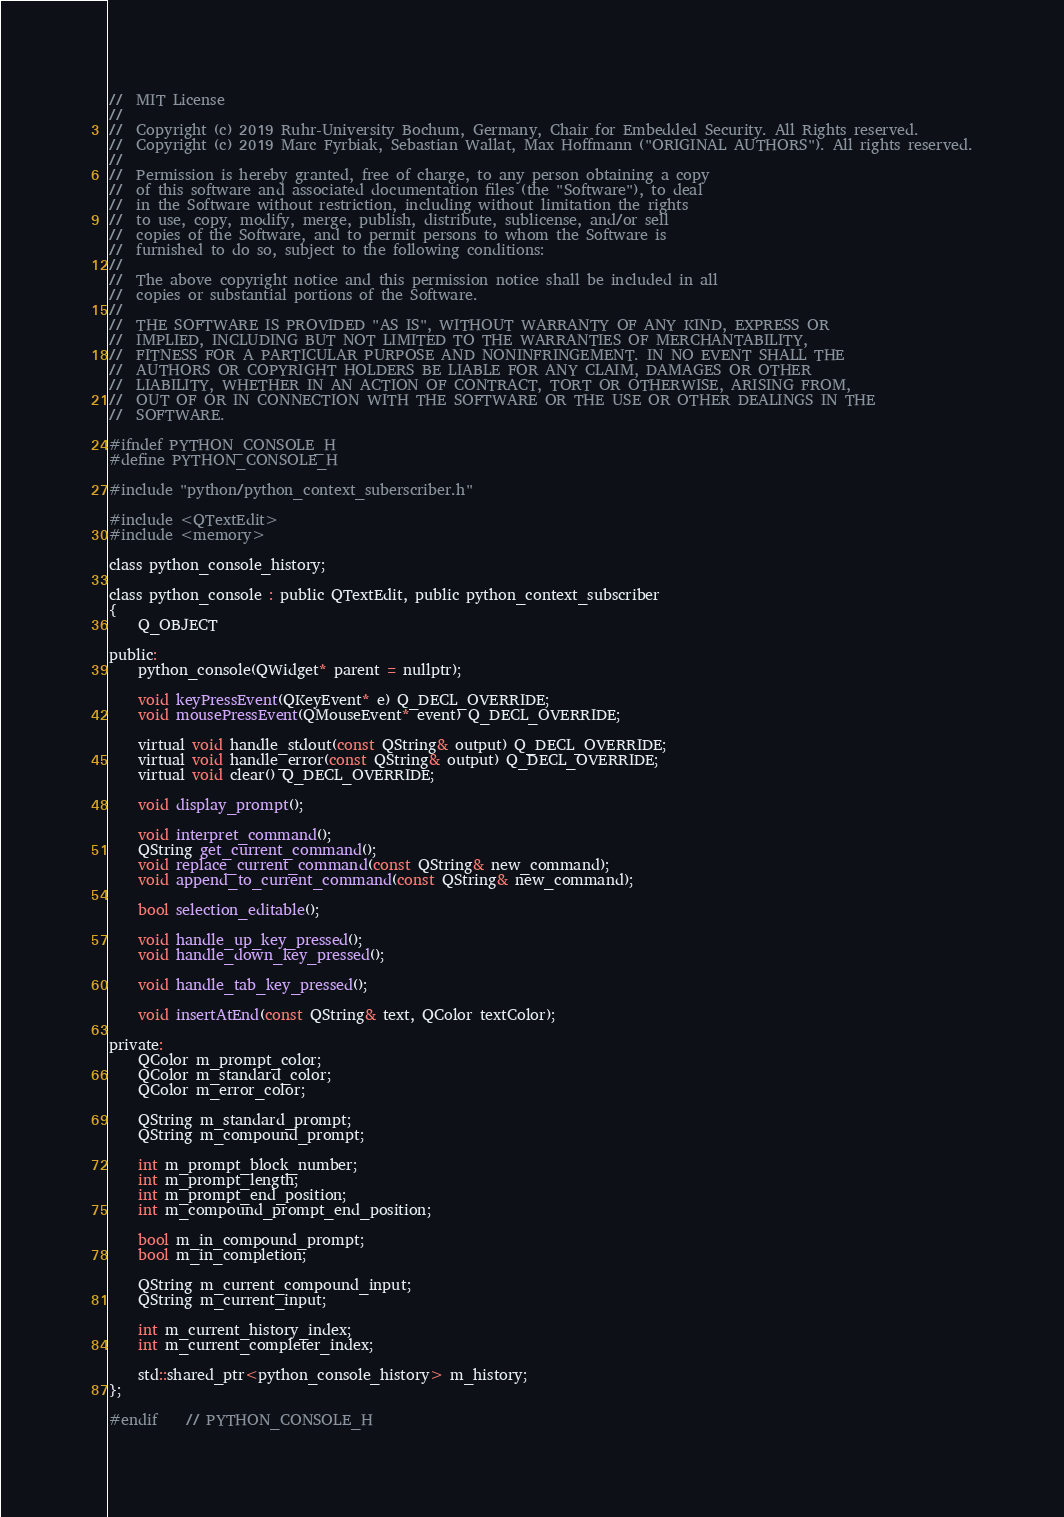<code> <loc_0><loc_0><loc_500><loc_500><_C_>//  MIT License
//
//  Copyright (c) 2019 Ruhr-University Bochum, Germany, Chair for Embedded Security. All Rights reserved.
//  Copyright (c) 2019 Marc Fyrbiak, Sebastian Wallat, Max Hoffmann ("ORIGINAL AUTHORS"). All rights reserved.
//
//  Permission is hereby granted, free of charge, to any person obtaining a copy
//  of this software and associated documentation files (the "Software"), to deal
//  in the Software without restriction, including without limitation the rights
//  to use, copy, modify, merge, publish, distribute, sublicense, and/or sell
//  copies of the Software, and to permit persons to whom the Software is
//  furnished to do so, subject to the following conditions:
//
//  The above copyright notice and this permission notice shall be included in all
//  copies or substantial portions of the Software.
//
//  THE SOFTWARE IS PROVIDED "AS IS", WITHOUT WARRANTY OF ANY KIND, EXPRESS OR
//  IMPLIED, INCLUDING BUT NOT LIMITED TO THE WARRANTIES OF MERCHANTABILITY,
//  FITNESS FOR A PARTICULAR PURPOSE AND NONINFRINGEMENT. IN NO EVENT SHALL THE
//  AUTHORS OR COPYRIGHT HOLDERS BE LIABLE FOR ANY CLAIM, DAMAGES OR OTHER
//  LIABILITY, WHETHER IN AN ACTION OF CONTRACT, TORT OR OTHERWISE, ARISING FROM,
//  OUT OF OR IN CONNECTION WITH THE SOFTWARE OR THE USE OR OTHER DEALINGS IN THE
//  SOFTWARE.

#ifndef PYTHON_CONSOLE_H
#define PYTHON_CONSOLE_H

#include "python/python_context_suberscriber.h"

#include <QTextEdit>
#include <memory>

class python_console_history;

class python_console : public QTextEdit, public python_context_subscriber
{
    Q_OBJECT

public:
    python_console(QWidget* parent = nullptr);

    void keyPressEvent(QKeyEvent* e) Q_DECL_OVERRIDE;
    void mousePressEvent(QMouseEvent* event) Q_DECL_OVERRIDE;

    virtual void handle_stdout(const QString& output) Q_DECL_OVERRIDE;
    virtual void handle_error(const QString& output) Q_DECL_OVERRIDE;
    virtual void clear() Q_DECL_OVERRIDE;

    void display_prompt();

    void interpret_command();
    QString get_current_command();
    void replace_current_command(const QString& new_command);
    void append_to_current_command(const QString& new_command);

    bool selection_editable();

    void handle_up_key_pressed();
    void handle_down_key_pressed();

    void handle_tab_key_pressed();

    void insertAtEnd(const QString& text, QColor textColor);

private:
    QColor m_prompt_color;
    QColor m_standard_color;
    QColor m_error_color;

    QString m_standard_prompt;
    QString m_compound_prompt;

    int m_prompt_block_number;
    int m_prompt_length;
    int m_prompt_end_position;
    int m_compound_prompt_end_position;

    bool m_in_compound_prompt;
    bool m_in_completion;

    QString m_current_compound_input;
    QString m_current_input;

    int m_current_history_index;
    int m_current_completer_index;

    std::shared_ptr<python_console_history> m_history;
};

#endif    // PYTHON_CONSOLE_H
</code> 